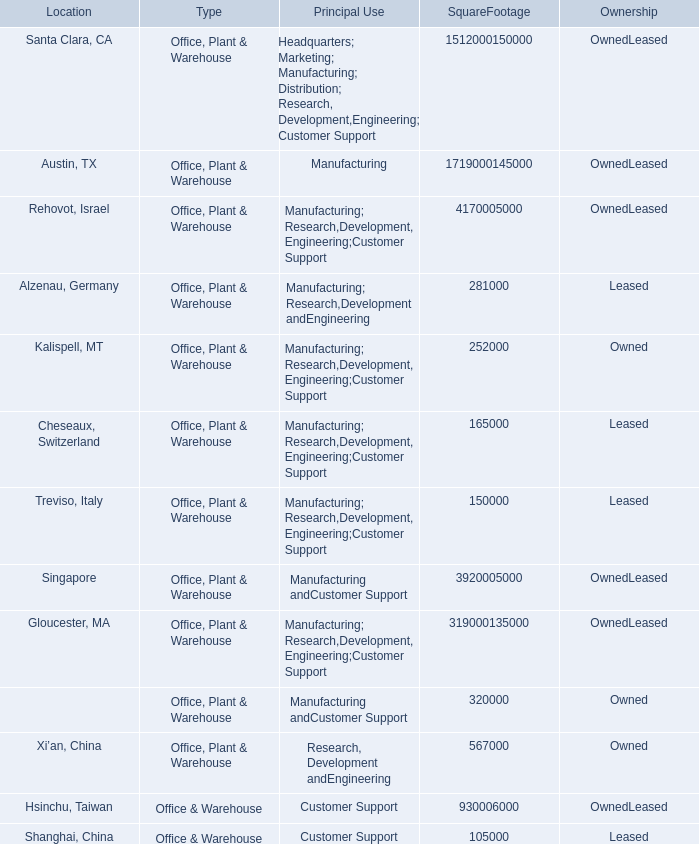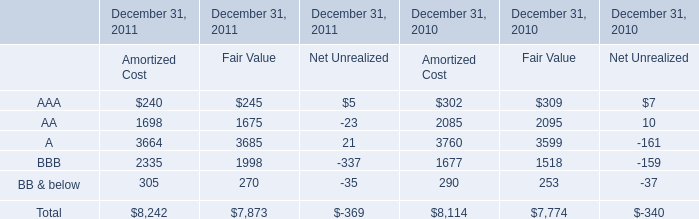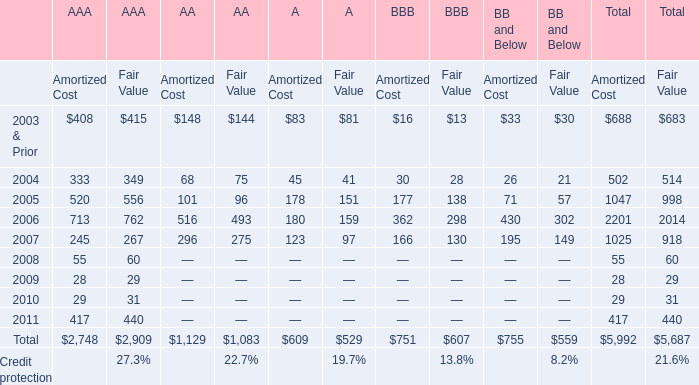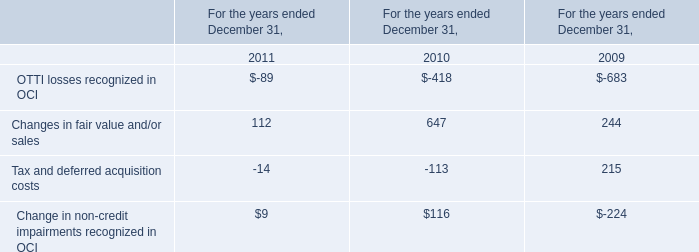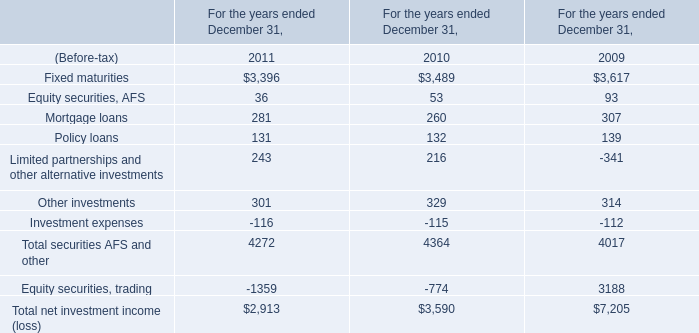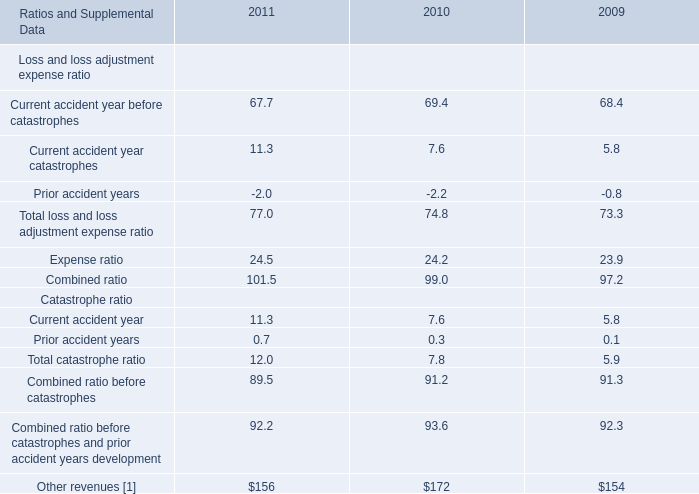what's the total amount of A of December 31, 2010 Fair Value, and Treviso, Italy of SquareFootage 1,512,000150,000 ? 
Computations: (3599.0 + 150000.0)
Answer: 153599.0. 